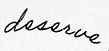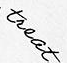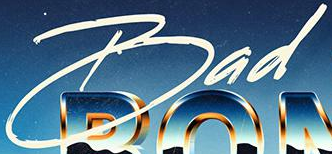What text appears in these images from left to right, separated by a semicolon? deserve; treat; Bad 